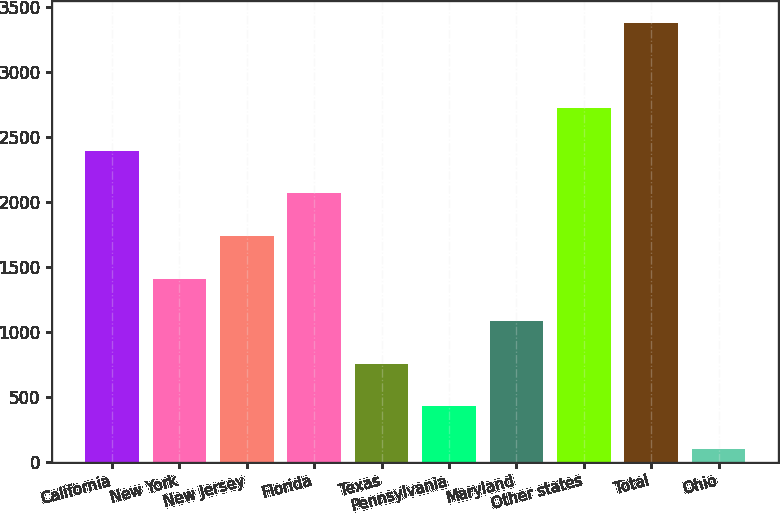Convert chart to OTSL. <chart><loc_0><loc_0><loc_500><loc_500><bar_chart><fcel>California<fcel>New York<fcel>New Jersey<fcel>Florida<fcel>Texas<fcel>Pennsylvania<fcel>Maryland<fcel>Other states<fcel>Total<fcel>Ohio<nl><fcel>2391.9<fcel>1408.8<fcel>1736.5<fcel>2064.2<fcel>753.4<fcel>425.7<fcel>1081.1<fcel>2719.6<fcel>3375<fcel>98<nl></chart> 